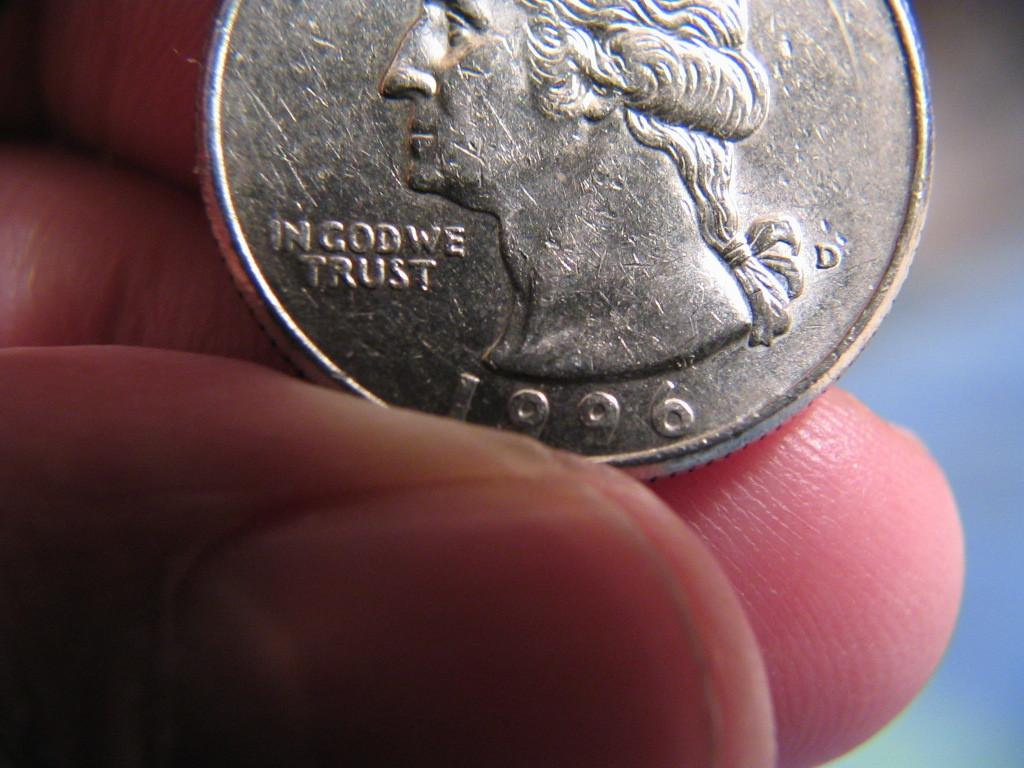<image>
Write a terse but informative summary of the picture. the year 1996 is on the silver coin 